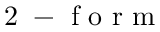<formula> <loc_0><loc_0><loc_500><loc_500>2 - f o r m</formula> 